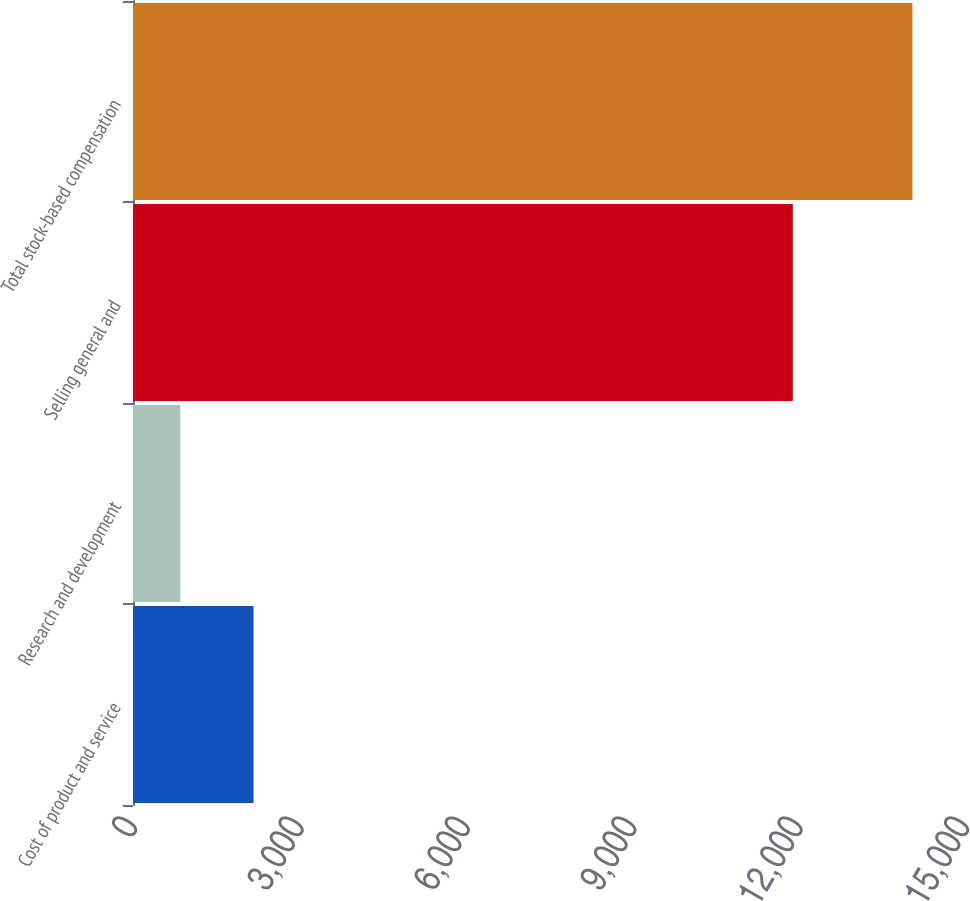Convert chart to OTSL. <chart><loc_0><loc_0><loc_500><loc_500><bar_chart><fcel>Cost of product and service<fcel>Research and development<fcel>Selling general and<fcel>Total stock-based compensation<nl><fcel>2173<fcel>853<fcel>11896<fcel>14053<nl></chart> 